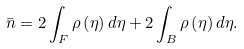Convert formula to latex. <formula><loc_0><loc_0><loc_500><loc_500>\bar { n } = 2 \int _ { F } \rho \left ( \eta \right ) d \eta + 2 \int _ { B } \rho \left ( \eta \right ) d \eta .</formula> 